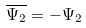Convert formula to latex. <formula><loc_0><loc_0><loc_500><loc_500>\overline { \Psi _ { 2 } } = - \Psi _ { 2 }</formula> 